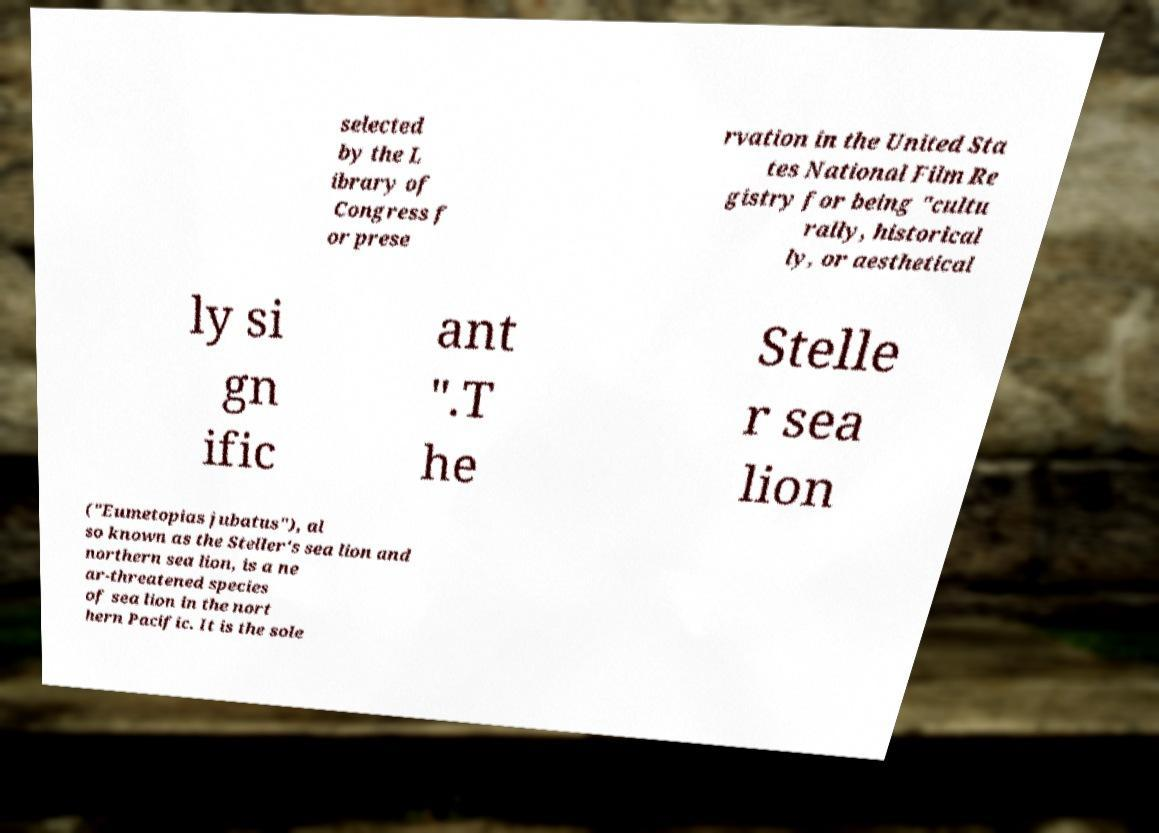Can you accurately transcribe the text from the provided image for me? selected by the L ibrary of Congress f or prese rvation in the United Sta tes National Film Re gistry for being "cultu rally, historical ly, or aesthetical ly si gn ific ant ".T he Stelle r sea lion ("Eumetopias jubatus"), al so known as the Steller's sea lion and northern sea lion, is a ne ar-threatened species of sea lion in the nort hern Pacific. It is the sole 